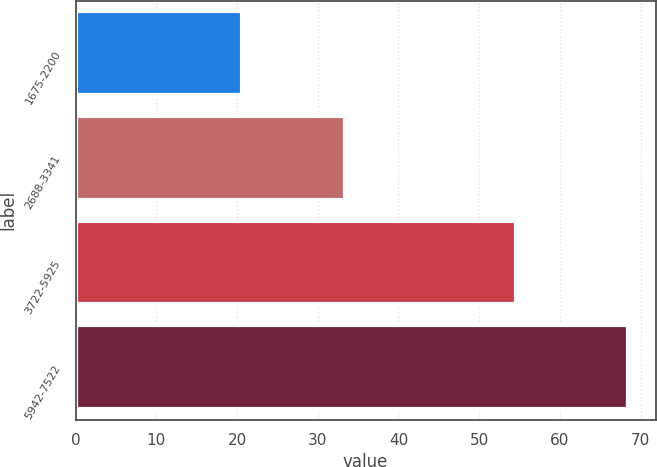Convert chart. <chart><loc_0><loc_0><loc_500><loc_500><bar_chart><fcel>1675-2200<fcel>2688-3341<fcel>3722-5925<fcel>5942-7522<nl><fcel>20.56<fcel>33.34<fcel>54.58<fcel>68.44<nl></chart> 